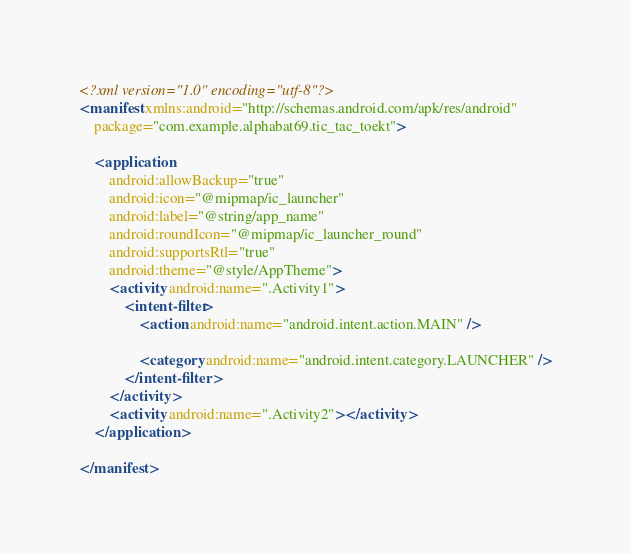<code> <loc_0><loc_0><loc_500><loc_500><_XML_><?xml version="1.0" encoding="utf-8"?>
<manifest xmlns:android="http://schemas.android.com/apk/res/android"
    package="com.example.alphabat69.tic_tac_toekt">

    <application
        android:allowBackup="true"
        android:icon="@mipmap/ic_launcher"
        android:label="@string/app_name"
        android:roundIcon="@mipmap/ic_launcher_round"
        android:supportsRtl="true"
        android:theme="@style/AppTheme">
        <activity android:name=".Activity1">
            <intent-filter>
                <action android:name="android.intent.action.MAIN" />

                <category android:name="android.intent.category.LAUNCHER" />
            </intent-filter>
        </activity>
        <activity android:name=".Activity2"></activity>
    </application>

</manifest></code> 